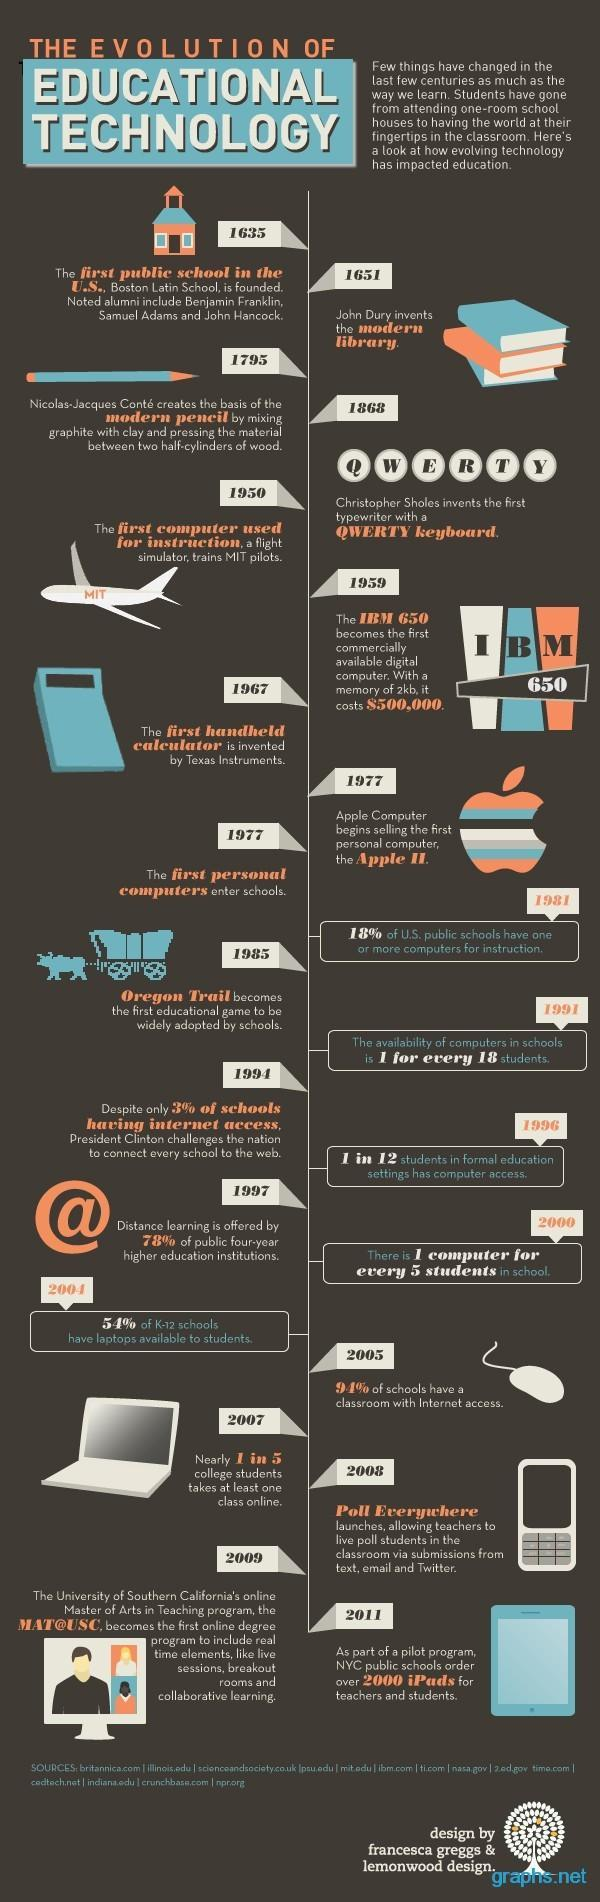When was the first computer used for instruction?
Answer the question with a short phrase. 1950 By which year was distance learning offered by 78% higher education institutions? 1997 In which year was Boston Latin School founded? 1635 In which year did John Dury invent the modern library? 1651 What was the price of IBM 650? $500,000 In which year was IBM 650 made commercially available? 1959 In which year was the basis of modern pencil created? 1795 In which year was MAT@USC launched? 2009 When did Christopher Sholes invent the typewriter ? 1868 Which year saw the invention of the first handheld calculator? 1967 